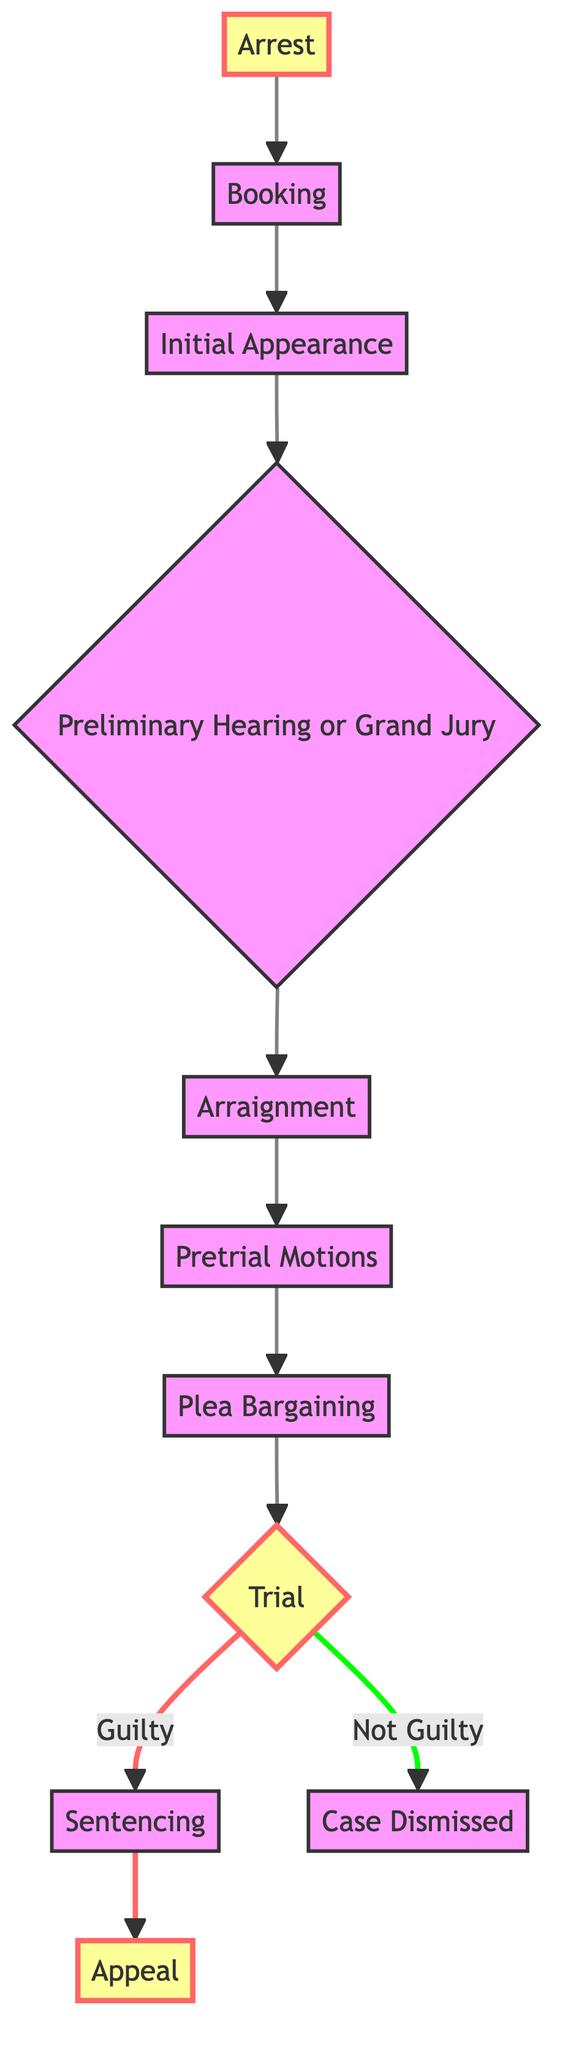What is the first step in the criminal justice process? The diagram shows that the first step following an arrest is "Booking".
Answer: Booking How many steps are involved in the criminal justice process before a trial? By counting the nodes from "Arrest" to "Arraignment", there are five steps: Arrest, Booking, Initial Appearance, Preliminary Hearing or Grand Jury, and Arraignment.
Answer: Five What happens if the verdict at trial is "Not Guilty"? The diagram indicates that if the verdict is "Not Guilty", the result is "Case Dismissed".
Answer: Case Dismissed What step follows the Arraignment? According to the diagram, after the Arraignment, the next step is "Pretrial Motions".
Answer: Pretrial Motions Which step involves the presentation of evidence? The diagram specifies that "Trial" is the step where evidence is presented.
Answer: Trial How many outcomes are shown after the trial? There are two outcomes shown after the trial: "Guilty" leading to "Sentencing" and "Not Guilty" leading to "Case Dismissed". So, the total is two outcomes.
Answer: Two What is the final step in the criminal justice process after being found guilty? The diagram states that after being found guilty, the final step is "Appeal".
Answer: Appeal What is the purpose of the Preliminary Hearing or Grand Jury? The diagram describes that this step is to determine if there is enough evidence to proceed to trial.
Answer: Enough evidence What kind of motions can be filed during the Pretrial Motions step? The diagram indicates that motions can include suppressing evidence or dismissing charges.
Answer: Suppress evidence What is the significance of the plea bargaining step? Plea bargaining is significant as it involves negotiating a possible plea deal to avoid trial.
Answer: Plea deal 